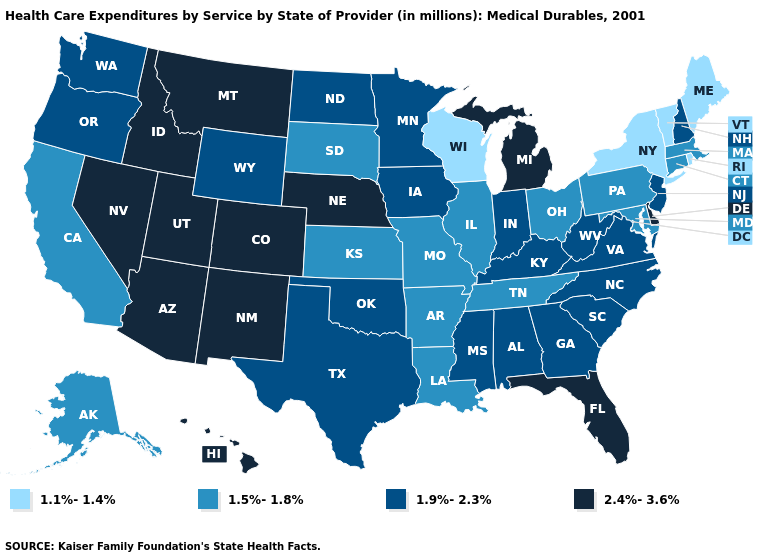What is the highest value in states that border Montana?
Be succinct. 2.4%-3.6%. Name the states that have a value in the range 2.4%-3.6%?
Keep it brief. Arizona, Colorado, Delaware, Florida, Hawaii, Idaho, Michigan, Montana, Nebraska, Nevada, New Mexico, Utah. Which states hav the highest value in the Northeast?
Be succinct. New Hampshire, New Jersey. What is the highest value in the USA?
Write a very short answer. 2.4%-3.6%. What is the value of Ohio?
Write a very short answer. 1.5%-1.8%. Name the states that have a value in the range 1.1%-1.4%?
Keep it brief. Maine, New York, Rhode Island, Vermont, Wisconsin. Which states have the lowest value in the USA?
Give a very brief answer. Maine, New York, Rhode Island, Vermont, Wisconsin. What is the lowest value in the West?
Be succinct. 1.5%-1.8%. Which states have the lowest value in the MidWest?
Short answer required. Wisconsin. Among the states that border Georgia , which have the highest value?
Give a very brief answer. Florida. Among the states that border Iowa , does Nebraska have the highest value?
Answer briefly. Yes. What is the value of West Virginia?
Keep it brief. 1.9%-2.3%. Is the legend a continuous bar?
Short answer required. No. Name the states that have a value in the range 1.5%-1.8%?
Be succinct. Alaska, Arkansas, California, Connecticut, Illinois, Kansas, Louisiana, Maryland, Massachusetts, Missouri, Ohio, Pennsylvania, South Dakota, Tennessee. Name the states that have a value in the range 1.5%-1.8%?
Keep it brief. Alaska, Arkansas, California, Connecticut, Illinois, Kansas, Louisiana, Maryland, Massachusetts, Missouri, Ohio, Pennsylvania, South Dakota, Tennessee. 